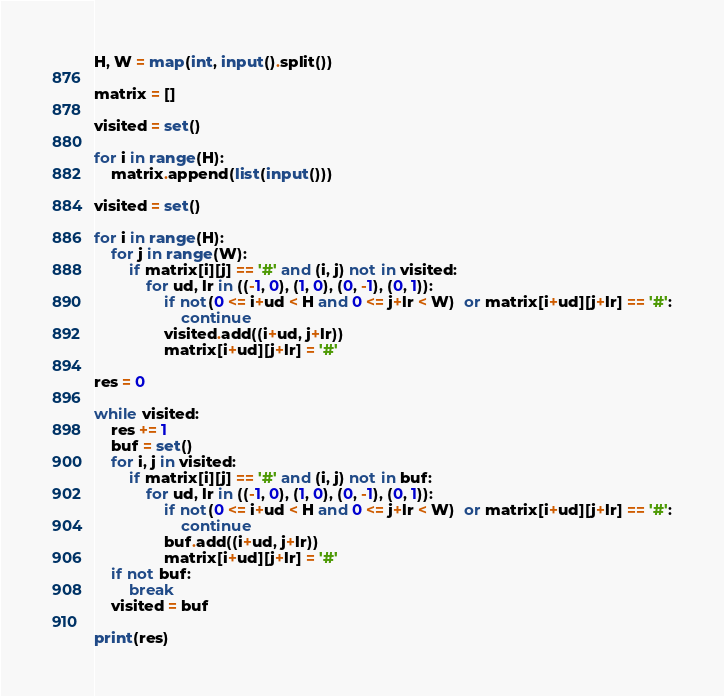<code> <loc_0><loc_0><loc_500><loc_500><_Python_>H, W = map(int, input().split())

matrix = []

visited = set()

for i in range(H):
    matrix.append(list(input()))

visited = set()

for i in range(H):
    for j in range(W):
        if matrix[i][j] == '#' and (i, j) not in visited:
            for ud, lr in ((-1, 0), (1, 0), (0, -1), (0, 1)):
                if not(0 <= i+ud < H and 0 <= j+lr < W)  or matrix[i+ud][j+lr] == '#':
                    continue
                visited.add((i+ud, j+lr))
                matrix[i+ud][j+lr] = '#'

res = 0

while visited:
    res += 1
    buf = set()
    for i, j in visited:
        if matrix[i][j] == '#' and (i, j) not in buf:
            for ud, lr in ((-1, 0), (1, 0), (0, -1), (0, 1)):
                if not(0 <= i+ud < H and 0 <= j+lr < W)  or matrix[i+ud][j+lr] == '#':
                    continue
                buf.add((i+ud, j+lr))
                matrix[i+ud][j+lr] = '#'
    if not buf:
        break
    visited = buf

print(res)

</code> 